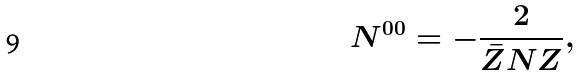<formula> <loc_0><loc_0><loc_500><loc_500>N ^ { 0 0 } = - \frac { 2 } { \bar { Z } N Z } ,</formula> 